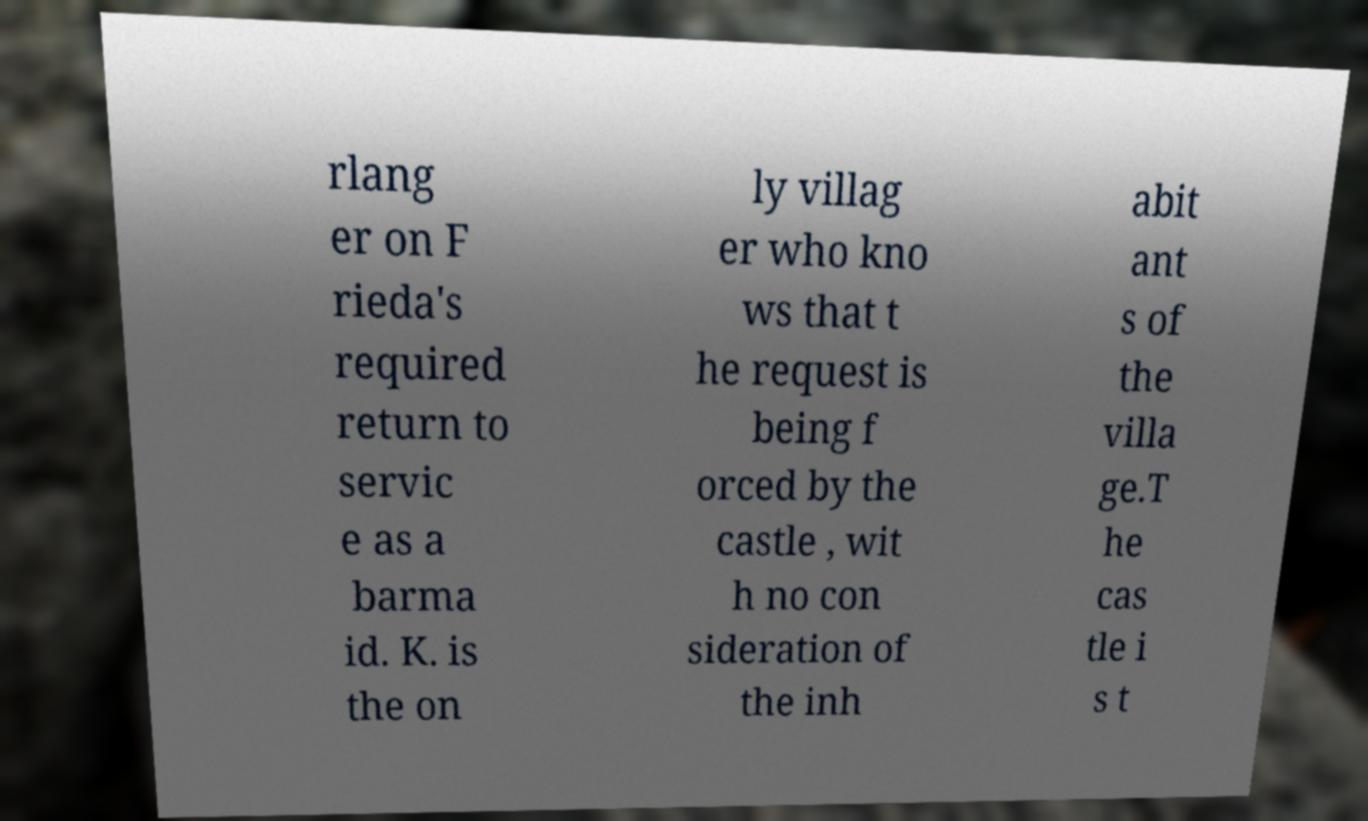Can you accurately transcribe the text from the provided image for me? rlang er on F rieda's required return to servic e as a barma id. K. is the on ly villag er who kno ws that t he request is being f orced by the castle , wit h no con sideration of the inh abit ant s of the villa ge.T he cas tle i s t 